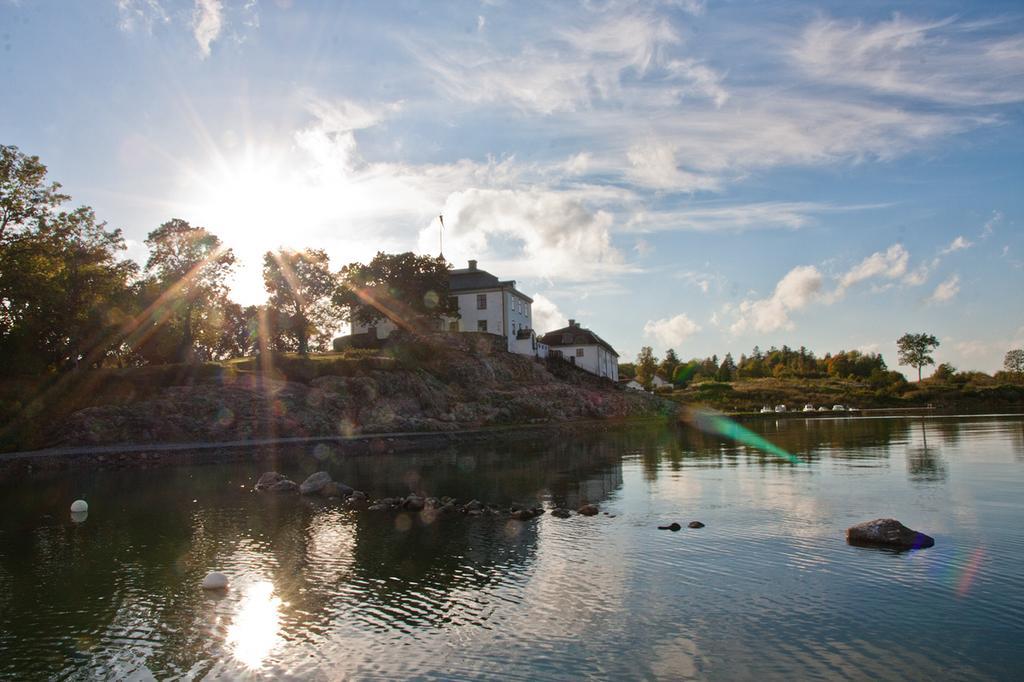Describe this image in one or two sentences. In this image I can see the water, few rocks and few white colored objects on the surface of the water. In the background I can see few buildings, few trees, the sky and the sun. 